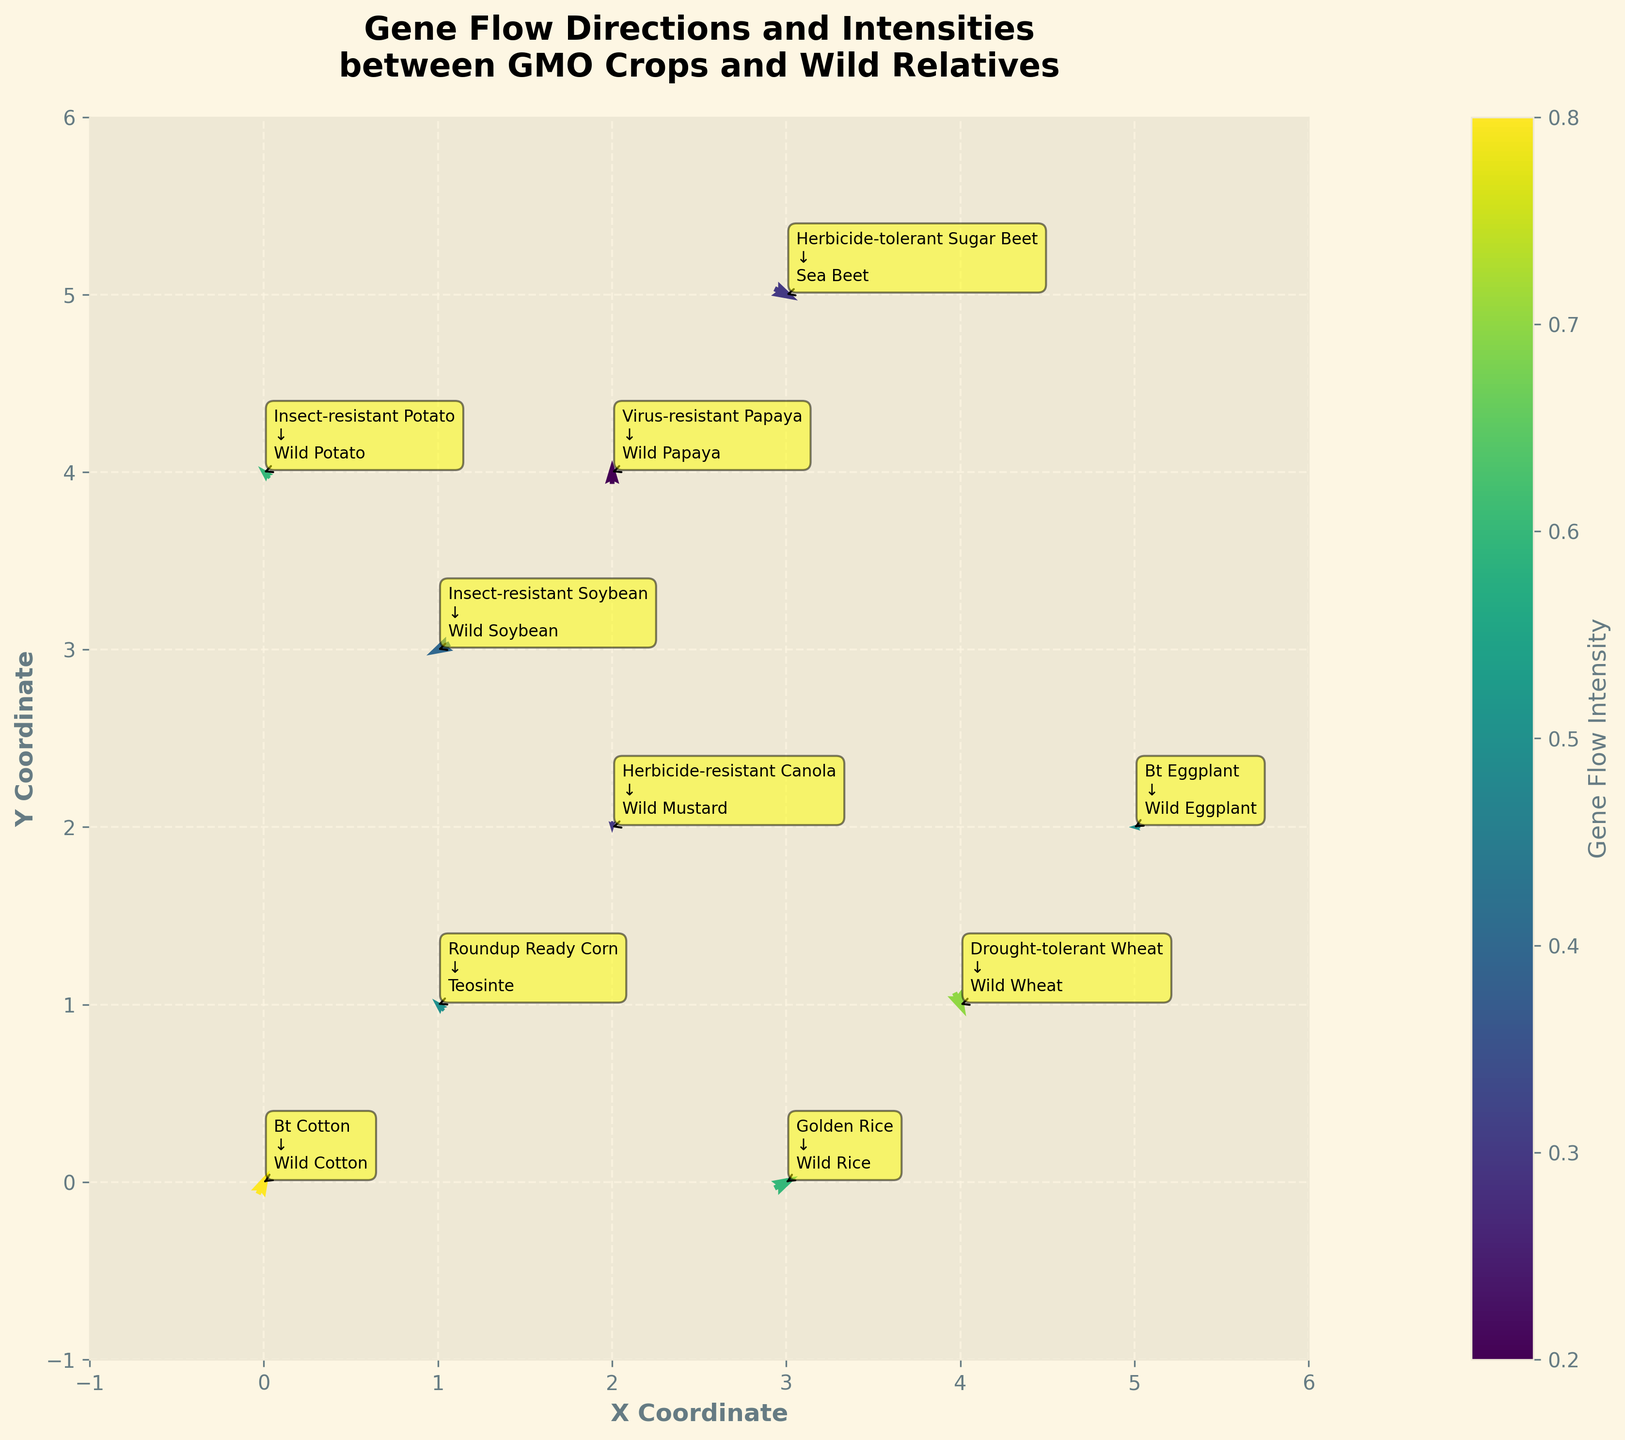Which crop has the highest gene flow intensity to its wild relative? By looking at the color gradients on the plot, which represents gene flow intensity, we can identify which arrow has the most intense color. Bt Cotton and Wild Cotton show the deepest color, which corresponds to the highest gene flow intensity.
Answer: Bt Cotton What is the direction and intensity of gene flow between Insect-resistant Soybean and its wild relative? Locate the starting point labeled “Insect-resistant Soybean” at (1,3) and observe the direction of the arrow. The arrow points down and to the left with coordinates changes of (-2, -1). The intensity is denoted by the color gradient, which corresponds to a value of 0.4.
Answer: Direction: (-2, -1), Intensity: 0.4 Compare the direction of gene flow between Roundup Ready Corn and Teosinte to that between Bt Eggplant and Wild Eggplant. To answer this, see the directions of arrows originating from Roundup Ready Corn and Bt Eggplant. Roundup Ready Corn has an arrow pointing to the top-left (-1, 1) while Bt Eggplant has an arrow pointing directly to the left (-1, 0).
Answer: Roundup Ready Corn: top-left (-1, 1), Bt Eggplant: left (-1, 0) Which GMO crop shows gene flow with a higher intensity, Golden Rice or Insect-resistant Potato? Compare the color gradients of the arrows for Golden Rice and Insect-resistant Potato. Golden Rice has a color corresponding to an intensity of 0.6, while Insect-resistant Potato also has an intensity of 0.6. This means they have equal gene flow intensity.
Answer: They have equal intensity How many crops show positive gene flow in the y-direction (upwards)? Examine the direction of the arrows for each crop, specifically focusing on whether the vertical component (v) is positive. Counting the arrows with upward directions, we find: Bt Cotton, Roundup Ready Corn, Virus-resistant Papaya, and Insect-resistant Potato.
Answer: 4 What is the total gene flow intensity for all crops combined? Sum the intensity values provided for each crop: 0.8 + 0.5 + 0.3 + 0.6 + 0.4 + 0.7 + 0.2 + 0.5 + 0.3 + 0.6 = 4.9.
Answer: 4.9 Which crops have arrows indicating no component in the x-direction (u = 0)? Identify arrows where the horizontal component (u) is zero. Examination reveals Herbicide-resistant Canola (u=0, v=-1) and Virus-resistant Papaya (u=0, v=2).
Answer: Herbicide-resistant Canola, Virus-resistant Papaya In which quadrant does the gene flow from Herbicide-resistant Canola to its wild relative occur? Determine the quadrant by looking at the arrow’s direction from Herbicide-resistant Canola. The arrow points downward (-y) with no x-component (u=0). It starts in quadrant I but solely moves downward, aligning with quadrant IV.
Answer: Quadrant IV 